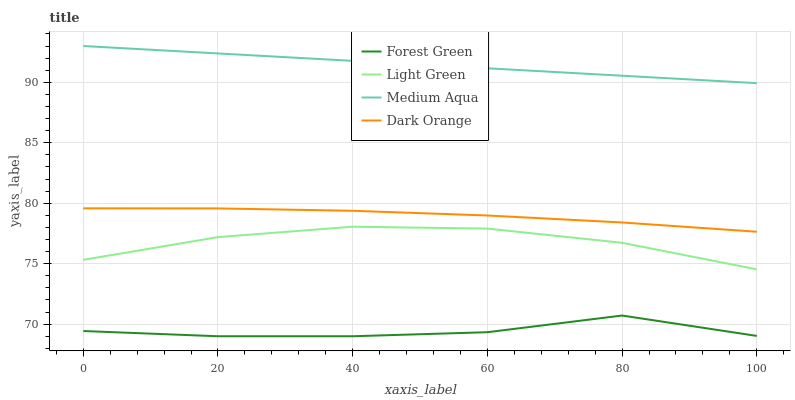Does Forest Green have the minimum area under the curve?
Answer yes or no. Yes. Does Medium Aqua have the maximum area under the curve?
Answer yes or no. Yes. Does Medium Aqua have the minimum area under the curve?
Answer yes or no. No. Does Forest Green have the maximum area under the curve?
Answer yes or no. No. Is Medium Aqua the smoothest?
Answer yes or no. Yes. Is Forest Green the roughest?
Answer yes or no. Yes. Is Forest Green the smoothest?
Answer yes or no. No. Is Medium Aqua the roughest?
Answer yes or no. No. Does Forest Green have the lowest value?
Answer yes or no. Yes. Does Medium Aqua have the lowest value?
Answer yes or no. No. Does Medium Aqua have the highest value?
Answer yes or no. Yes. Does Forest Green have the highest value?
Answer yes or no. No. Is Forest Green less than Medium Aqua?
Answer yes or no. Yes. Is Medium Aqua greater than Forest Green?
Answer yes or no. Yes. Does Forest Green intersect Medium Aqua?
Answer yes or no. No. 